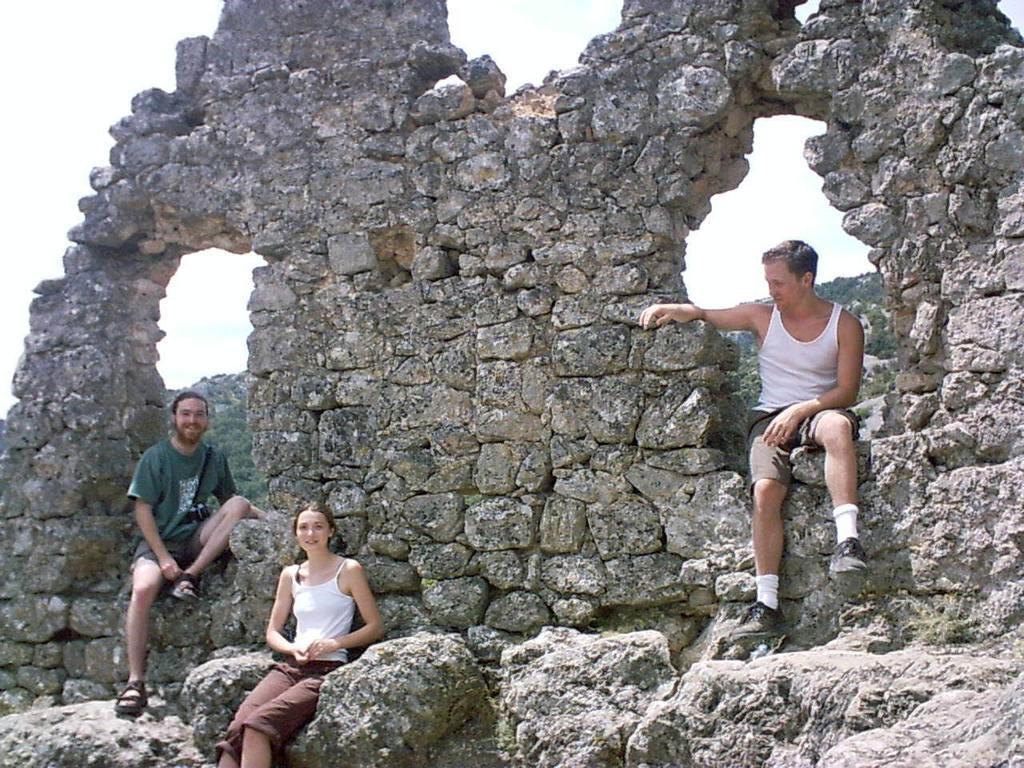Describe this image in one or two sentences. On the left side, there is a person smiling and sitting on a stone wall. Beside him, there is a woman in white color T-Shirt, smiling and sitting on a rock. On the right side, there is a person in a white color T-Shirt, smiling and sitting on the stone wall. In the background, there is a mountain and there is sky. 